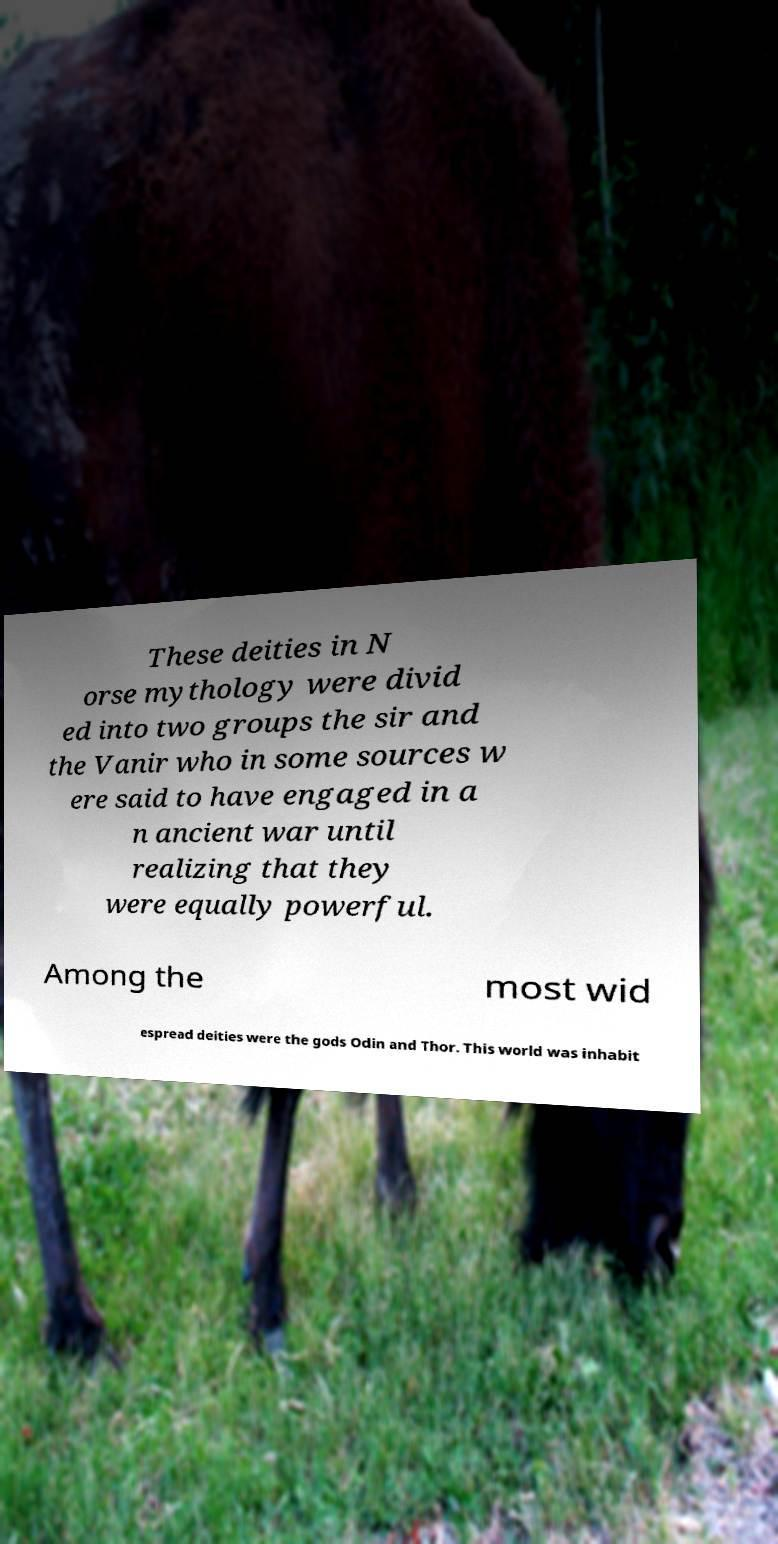Can you accurately transcribe the text from the provided image for me? These deities in N orse mythology were divid ed into two groups the sir and the Vanir who in some sources w ere said to have engaged in a n ancient war until realizing that they were equally powerful. Among the most wid espread deities were the gods Odin and Thor. This world was inhabit 